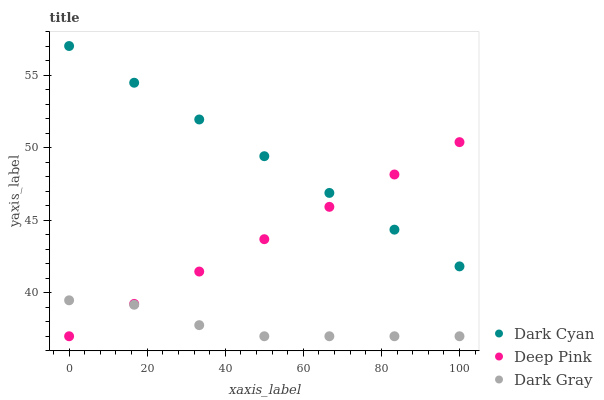Does Dark Gray have the minimum area under the curve?
Answer yes or no. Yes. Does Dark Cyan have the maximum area under the curve?
Answer yes or no. Yes. Does Deep Pink have the minimum area under the curve?
Answer yes or no. No. Does Deep Pink have the maximum area under the curve?
Answer yes or no. No. Is Deep Pink the smoothest?
Answer yes or no. Yes. Is Dark Gray the roughest?
Answer yes or no. Yes. Is Dark Gray the smoothest?
Answer yes or no. No. Is Deep Pink the roughest?
Answer yes or no. No. Does Dark Gray have the lowest value?
Answer yes or no. Yes. Does Dark Cyan have the highest value?
Answer yes or no. Yes. Does Deep Pink have the highest value?
Answer yes or no. No. Is Dark Gray less than Dark Cyan?
Answer yes or no. Yes. Is Dark Cyan greater than Dark Gray?
Answer yes or no. Yes. Does Dark Cyan intersect Deep Pink?
Answer yes or no. Yes. Is Dark Cyan less than Deep Pink?
Answer yes or no. No. Is Dark Cyan greater than Deep Pink?
Answer yes or no. No. Does Dark Gray intersect Dark Cyan?
Answer yes or no. No. 